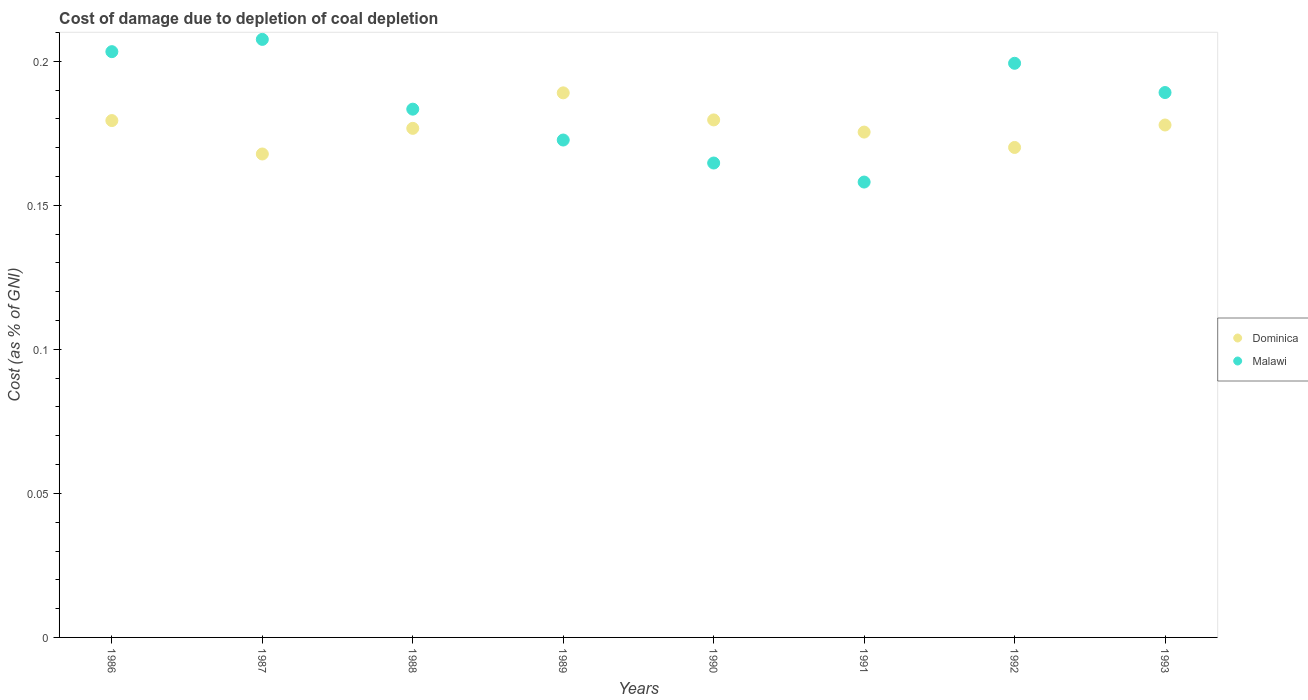What is the cost of damage caused due to coal depletion in Dominica in 1988?
Your answer should be very brief. 0.18. Across all years, what is the maximum cost of damage caused due to coal depletion in Dominica?
Ensure brevity in your answer.  0.19. Across all years, what is the minimum cost of damage caused due to coal depletion in Dominica?
Give a very brief answer. 0.17. What is the total cost of damage caused due to coal depletion in Dominica in the graph?
Your response must be concise. 1.42. What is the difference between the cost of damage caused due to coal depletion in Dominica in 1990 and that in 1991?
Your answer should be very brief. 0. What is the difference between the cost of damage caused due to coal depletion in Dominica in 1989 and the cost of damage caused due to coal depletion in Malawi in 1987?
Your response must be concise. -0.02. What is the average cost of damage caused due to coal depletion in Dominica per year?
Offer a terse response. 0.18. In the year 1989, what is the difference between the cost of damage caused due to coal depletion in Malawi and cost of damage caused due to coal depletion in Dominica?
Your answer should be very brief. -0.02. What is the ratio of the cost of damage caused due to coal depletion in Dominica in 1988 to that in 1991?
Give a very brief answer. 1.01. What is the difference between the highest and the second highest cost of damage caused due to coal depletion in Dominica?
Your response must be concise. 0.01. What is the difference between the highest and the lowest cost of damage caused due to coal depletion in Dominica?
Your answer should be compact. 0.02. In how many years, is the cost of damage caused due to coal depletion in Dominica greater than the average cost of damage caused due to coal depletion in Dominica taken over all years?
Provide a short and direct response. 4. Does the cost of damage caused due to coal depletion in Dominica monotonically increase over the years?
Ensure brevity in your answer.  No. Is the cost of damage caused due to coal depletion in Malawi strictly less than the cost of damage caused due to coal depletion in Dominica over the years?
Your answer should be very brief. No. Does the graph contain any zero values?
Offer a very short reply. No. Does the graph contain grids?
Make the answer very short. No. Where does the legend appear in the graph?
Ensure brevity in your answer.  Center right. How are the legend labels stacked?
Your answer should be compact. Vertical. What is the title of the graph?
Give a very brief answer. Cost of damage due to depletion of coal depletion. Does "El Salvador" appear as one of the legend labels in the graph?
Make the answer very short. No. What is the label or title of the Y-axis?
Make the answer very short. Cost (as % of GNI). What is the Cost (as % of GNI) of Dominica in 1986?
Keep it short and to the point. 0.18. What is the Cost (as % of GNI) of Malawi in 1986?
Provide a succinct answer. 0.2. What is the Cost (as % of GNI) of Dominica in 1987?
Provide a succinct answer. 0.17. What is the Cost (as % of GNI) in Malawi in 1987?
Offer a terse response. 0.21. What is the Cost (as % of GNI) in Dominica in 1988?
Give a very brief answer. 0.18. What is the Cost (as % of GNI) in Malawi in 1988?
Your response must be concise. 0.18. What is the Cost (as % of GNI) of Dominica in 1989?
Ensure brevity in your answer.  0.19. What is the Cost (as % of GNI) of Malawi in 1989?
Make the answer very short. 0.17. What is the Cost (as % of GNI) of Dominica in 1990?
Provide a succinct answer. 0.18. What is the Cost (as % of GNI) in Malawi in 1990?
Make the answer very short. 0.16. What is the Cost (as % of GNI) in Dominica in 1991?
Your answer should be compact. 0.18. What is the Cost (as % of GNI) in Malawi in 1991?
Provide a short and direct response. 0.16. What is the Cost (as % of GNI) in Dominica in 1992?
Your response must be concise. 0.17. What is the Cost (as % of GNI) in Malawi in 1992?
Your answer should be very brief. 0.2. What is the Cost (as % of GNI) in Dominica in 1993?
Give a very brief answer. 0.18. What is the Cost (as % of GNI) of Malawi in 1993?
Provide a succinct answer. 0.19. Across all years, what is the maximum Cost (as % of GNI) in Dominica?
Give a very brief answer. 0.19. Across all years, what is the maximum Cost (as % of GNI) in Malawi?
Your answer should be compact. 0.21. Across all years, what is the minimum Cost (as % of GNI) of Dominica?
Your answer should be compact. 0.17. Across all years, what is the minimum Cost (as % of GNI) in Malawi?
Your answer should be compact. 0.16. What is the total Cost (as % of GNI) of Dominica in the graph?
Offer a very short reply. 1.42. What is the total Cost (as % of GNI) in Malawi in the graph?
Keep it short and to the point. 1.48. What is the difference between the Cost (as % of GNI) of Dominica in 1986 and that in 1987?
Your answer should be compact. 0.01. What is the difference between the Cost (as % of GNI) of Malawi in 1986 and that in 1987?
Your answer should be very brief. -0. What is the difference between the Cost (as % of GNI) in Dominica in 1986 and that in 1988?
Provide a short and direct response. 0. What is the difference between the Cost (as % of GNI) of Malawi in 1986 and that in 1988?
Your response must be concise. 0.02. What is the difference between the Cost (as % of GNI) of Dominica in 1986 and that in 1989?
Offer a terse response. -0.01. What is the difference between the Cost (as % of GNI) in Malawi in 1986 and that in 1989?
Offer a terse response. 0.03. What is the difference between the Cost (as % of GNI) in Dominica in 1986 and that in 1990?
Give a very brief answer. -0. What is the difference between the Cost (as % of GNI) of Malawi in 1986 and that in 1990?
Your answer should be very brief. 0.04. What is the difference between the Cost (as % of GNI) in Dominica in 1986 and that in 1991?
Provide a succinct answer. 0. What is the difference between the Cost (as % of GNI) in Malawi in 1986 and that in 1991?
Provide a succinct answer. 0.05. What is the difference between the Cost (as % of GNI) in Dominica in 1986 and that in 1992?
Keep it short and to the point. 0.01. What is the difference between the Cost (as % of GNI) of Malawi in 1986 and that in 1992?
Your answer should be very brief. 0. What is the difference between the Cost (as % of GNI) of Dominica in 1986 and that in 1993?
Provide a succinct answer. 0. What is the difference between the Cost (as % of GNI) in Malawi in 1986 and that in 1993?
Your answer should be very brief. 0.01. What is the difference between the Cost (as % of GNI) of Dominica in 1987 and that in 1988?
Make the answer very short. -0.01. What is the difference between the Cost (as % of GNI) in Malawi in 1987 and that in 1988?
Keep it short and to the point. 0.02. What is the difference between the Cost (as % of GNI) in Dominica in 1987 and that in 1989?
Your answer should be very brief. -0.02. What is the difference between the Cost (as % of GNI) in Malawi in 1987 and that in 1989?
Provide a succinct answer. 0.03. What is the difference between the Cost (as % of GNI) of Dominica in 1987 and that in 1990?
Provide a short and direct response. -0.01. What is the difference between the Cost (as % of GNI) in Malawi in 1987 and that in 1990?
Keep it short and to the point. 0.04. What is the difference between the Cost (as % of GNI) in Dominica in 1987 and that in 1991?
Provide a short and direct response. -0.01. What is the difference between the Cost (as % of GNI) of Malawi in 1987 and that in 1991?
Your answer should be compact. 0.05. What is the difference between the Cost (as % of GNI) of Dominica in 1987 and that in 1992?
Your response must be concise. -0. What is the difference between the Cost (as % of GNI) in Malawi in 1987 and that in 1992?
Keep it short and to the point. 0.01. What is the difference between the Cost (as % of GNI) of Dominica in 1987 and that in 1993?
Give a very brief answer. -0.01. What is the difference between the Cost (as % of GNI) in Malawi in 1987 and that in 1993?
Offer a very short reply. 0.02. What is the difference between the Cost (as % of GNI) of Dominica in 1988 and that in 1989?
Your answer should be compact. -0.01. What is the difference between the Cost (as % of GNI) in Malawi in 1988 and that in 1989?
Your answer should be compact. 0.01. What is the difference between the Cost (as % of GNI) of Dominica in 1988 and that in 1990?
Ensure brevity in your answer.  -0. What is the difference between the Cost (as % of GNI) of Malawi in 1988 and that in 1990?
Offer a terse response. 0.02. What is the difference between the Cost (as % of GNI) in Dominica in 1988 and that in 1991?
Offer a very short reply. 0. What is the difference between the Cost (as % of GNI) in Malawi in 1988 and that in 1991?
Your response must be concise. 0.03. What is the difference between the Cost (as % of GNI) in Dominica in 1988 and that in 1992?
Offer a very short reply. 0.01. What is the difference between the Cost (as % of GNI) of Malawi in 1988 and that in 1992?
Give a very brief answer. -0.02. What is the difference between the Cost (as % of GNI) in Dominica in 1988 and that in 1993?
Your answer should be compact. -0. What is the difference between the Cost (as % of GNI) in Malawi in 1988 and that in 1993?
Your answer should be compact. -0.01. What is the difference between the Cost (as % of GNI) of Dominica in 1989 and that in 1990?
Your answer should be compact. 0.01. What is the difference between the Cost (as % of GNI) in Malawi in 1989 and that in 1990?
Ensure brevity in your answer.  0.01. What is the difference between the Cost (as % of GNI) of Dominica in 1989 and that in 1991?
Ensure brevity in your answer.  0.01. What is the difference between the Cost (as % of GNI) in Malawi in 1989 and that in 1991?
Give a very brief answer. 0.01. What is the difference between the Cost (as % of GNI) of Dominica in 1989 and that in 1992?
Provide a short and direct response. 0.02. What is the difference between the Cost (as % of GNI) of Malawi in 1989 and that in 1992?
Make the answer very short. -0.03. What is the difference between the Cost (as % of GNI) of Dominica in 1989 and that in 1993?
Your response must be concise. 0.01. What is the difference between the Cost (as % of GNI) of Malawi in 1989 and that in 1993?
Provide a succinct answer. -0.02. What is the difference between the Cost (as % of GNI) in Dominica in 1990 and that in 1991?
Offer a terse response. 0. What is the difference between the Cost (as % of GNI) in Malawi in 1990 and that in 1991?
Your answer should be compact. 0.01. What is the difference between the Cost (as % of GNI) in Dominica in 1990 and that in 1992?
Ensure brevity in your answer.  0.01. What is the difference between the Cost (as % of GNI) of Malawi in 1990 and that in 1992?
Your answer should be compact. -0.03. What is the difference between the Cost (as % of GNI) in Dominica in 1990 and that in 1993?
Ensure brevity in your answer.  0. What is the difference between the Cost (as % of GNI) of Malawi in 1990 and that in 1993?
Ensure brevity in your answer.  -0.02. What is the difference between the Cost (as % of GNI) of Dominica in 1991 and that in 1992?
Provide a succinct answer. 0.01. What is the difference between the Cost (as % of GNI) of Malawi in 1991 and that in 1992?
Make the answer very short. -0.04. What is the difference between the Cost (as % of GNI) of Dominica in 1991 and that in 1993?
Give a very brief answer. -0. What is the difference between the Cost (as % of GNI) of Malawi in 1991 and that in 1993?
Your answer should be very brief. -0.03. What is the difference between the Cost (as % of GNI) in Dominica in 1992 and that in 1993?
Give a very brief answer. -0.01. What is the difference between the Cost (as % of GNI) of Malawi in 1992 and that in 1993?
Offer a very short reply. 0.01. What is the difference between the Cost (as % of GNI) in Dominica in 1986 and the Cost (as % of GNI) in Malawi in 1987?
Keep it short and to the point. -0.03. What is the difference between the Cost (as % of GNI) of Dominica in 1986 and the Cost (as % of GNI) of Malawi in 1988?
Give a very brief answer. -0. What is the difference between the Cost (as % of GNI) in Dominica in 1986 and the Cost (as % of GNI) in Malawi in 1989?
Offer a very short reply. 0.01. What is the difference between the Cost (as % of GNI) of Dominica in 1986 and the Cost (as % of GNI) of Malawi in 1990?
Provide a short and direct response. 0.01. What is the difference between the Cost (as % of GNI) of Dominica in 1986 and the Cost (as % of GNI) of Malawi in 1991?
Make the answer very short. 0.02. What is the difference between the Cost (as % of GNI) in Dominica in 1986 and the Cost (as % of GNI) in Malawi in 1992?
Give a very brief answer. -0.02. What is the difference between the Cost (as % of GNI) in Dominica in 1986 and the Cost (as % of GNI) in Malawi in 1993?
Your answer should be compact. -0.01. What is the difference between the Cost (as % of GNI) of Dominica in 1987 and the Cost (as % of GNI) of Malawi in 1988?
Ensure brevity in your answer.  -0.02. What is the difference between the Cost (as % of GNI) in Dominica in 1987 and the Cost (as % of GNI) in Malawi in 1989?
Ensure brevity in your answer.  -0. What is the difference between the Cost (as % of GNI) in Dominica in 1987 and the Cost (as % of GNI) in Malawi in 1990?
Your response must be concise. 0. What is the difference between the Cost (as % of GNI) of Dominica in 1987 and the Cost (as % of GNI) of Malawi in 1991?
Make the answer very short. 0.01. What is the difference between the Cost (as % of GNI) in Dominica in 1987 and the Cost (as % of GNI) in Malawi in 1992?
Offer a terse response. -0.03. What is the difference between the Cost (as % of GNI) of Dominica in 1987 and the Cost (as % of GNI) of Malawi in 1993?
Your answer should be compact. -0.02. What is the difference between the Cost (as % of GNI) of Dominica in 1988 and the Cost (as % of GNI) of Malawi in 1989?
Ensure brevity in your answer.  0. What is the difference between the Cost (as % of GNI) in Dominica in 1988 and the Cost (as % of GNI) in Malawi in 1990?
Your response must be concise. 0.01. What is the difference between the Cost (as % of GNI) of Dominica in 1988 and the Cost (as % of GNI) of Malawi in 1991?
Your answer should be very brief. 0.02. What is the difference between the Cost (as % of GNI) of Dominica in 1988 and the Cost (as % of GNI) of Malawi in 1992?
Make the answer very short. -0.02. What is the difference between the Cost (as % of GNI) in Dominica in 1988 and the Cost (as % of GNI) in Malawi in 1993?
Provide a short and direct response. -0.01. What is the difference between the Cost (as % of GNI) of Dominica in 1989 and the Cost (as % of GNI) of Malawi in 1990?
Provide a succinct answer. 0.02. What is the difference between the Cost (as % of GNI) in Dominica in 1989 and the Cost (as % of GNI) in Malawi in 1991?
Keep it short and to the point. 0.03. What is the difference between the Cost (as % of GNI) of Dominica in 1989 and the Cost (as % of GNI) of Malawi in 1992?
Make the answer very short. -0.01. What is the difference between the Cost (as % of GNI) of Dominica in 1989 and the Cost (as % of GNI) of Malawi in 1993?
Make the answer very short. -0. What is the difference between the Cost (as % of GNI) in Dominica in 1990 and the Cost (as % of GNI) in Malawi in 1991?
Ensure brevity in your answer.  0.02. What is the difference between the Cost (as % of GNI) in Dominica in 1990 and the Cost (as % of GNI) in Malawi in 1992?
Give a very brief answer. -0.02. What is the difference between the Cost (as % of GNI) of Dominica in 1990 and the Cost (as % of GNI) of Malawi in 1993?
Keep it short and to the point. -0.01. What is the difference between the Cost (as % of GNI) in Dominica in 1991 and the Cost (as % of GNI) in Malawi in 1992?
Your answer should be compact. -0.02. What is the difference between the Cost (as % of GNI) of Dominica in 1991 and the Cost (as % of GNI) of Malawi in 1993?
Give a very brief answer. -0.01. What is the difference between the Cost (as % of GNI) in Dominica in 1992 and the Cost (as % of GNI) in Malawi in 1993?
Provide a short and direct response. -0.02. What is the average Cost (as % of GNI) in Dominica per year?
Offer a very short reply. 0.18. What is the average Cost (as % of GNI) of Malawi per year?
Offer a very short reply. 0.18. In the year 1986, what is the difference between the Cost (as % of GNI) of Dominica and Cost (as % of GNI) of Malawi?
Your answer should be compact. -0.02. In the year 1987, what is the difference between the Cost (as % of GNI) of Dominica and Cost (as % of GNI) of Malawi?
Ensure brevity in your answer.  -0.04. In the year 1988, what is the difference between the Cost (as % of GNI) of Dominica and Cost (as % of GNI) of Malawi?
Offer a terse response. -0.01. In the year 1989, what is the difference between the Cost (as % of GNI) in Dominica and Cost (as % of GNI) in Malawi?
Ensure brevity in your answer.  0.02. In the year 1990, what is the difference between the Cost (as % of GNI) in Dominica and Cost (as % of GNI) in Malawi?
Give a very brief answer. 0.01. In the year 1991, what is the difference between the Cost (as % of GNI) in Dominica and Cost (as % of GNI) in Malawi?
Offer a terse response. 0.02. In the year 1992, what is the difference between the Cost (as % of GNI) in Dominica and Cost (as % of GNI) in Malawi?
Offer a very short reply. -0.03. In the year 1993, what is the difference between the Cost (as % of GNI) in Dominica and Cost (as % of GNI) in Malawi?
Your answer should be compact. -0.01. What is the ratio of the Cost (as % of GNI) of Dominica in 1986 to that in 1987?
Offer a very short reply. 1.07. What is the ratio of the Cost (as % of GNI) in Malawi in 1986 to that in 1987?
Provide a short and direct response. 0.98. What is the ratio of the Cost (as % of GNI) of Dominica in 1986 to that in 1988?
Offer a terse response. 1.02. What is the ratio of the Cost (as % of GNI) of Malawi in 1986 to that in 1988?
Offer a terse response. 1.11. What is the ratio of the Cost (as % of GNI) of Dominica in 1986 to that in 1989?
Give a very brief answer. 0.95. What is the ratio of the Cost (as % of GNI) in Malawi in 1986 to that in 1989?
Keep it short and to the point. 1.18. What is the ratio of the Cost (as % of GNI) of Malawi in 1986 to that in 1990?
Your answer should be very brief. 1.23. What is the ratio of the Cost (as % of GNI) in Dominica in 1986 to that in 1991?
Your answer should be very brief. 1.02. What is the ratio of the Cost (as % of GNI) in Malawi in 1986 to that in 1991?
Make the answer very short. 1.29. What is the ratio of the Cost (as % of GNI) of Dominica in 1986 to that in 1992?
Provide a short and direct response. 1.05. What is the ratio of the Cost (as % of GNI) of Malawi in 1986 to that in 1992?
Provide a succinct answer. 1.02. What is the ratio of the Cost (as % of GNI) in Dominica in 1986 to that in 1993?
Keep it short and to the point. 1.01. What is the ratio of the Cost (as % of GNI) in Malawi in 1986 to that in 1993?
Your answer should be very brief. 1.07. What is the ratio of the Cost (as % of GNI) of Dominica in 1987 to that in 1988?
Provide a short and direct response. 0.95. What is the ratio of the Cost (as % of GNI) of Malawi in 1987 to that in 1988?
Offer a very short reply. 1.13. What is the ratio of the Cost (as % of GNI) of Dominica in 1987 to that in 1989?
Your response must be concise. 0.89. What is the ratio of the Cost (as % of GNI) in Malawi in 1987 to that in 1989?
Keep it short and to the point. 1.2. What is the ratio of the Cost (as % of GNI) of Dominica in 1987 to that in 1990?
Provide a succinct answer. 0.93. What is the ratio of the Cost (as % of GNI) in Malawi in 1987 to that in 1990?
Offer a very short reply. 1.26. What is the ratio of the Cost (as % of GNI) in Dominica in 1987 to that in 1991?
Provide a short and direct response. 0.96. What is the ratio of the Cost (as % of GNI) in Malawi in 1987 to that in 1991?
Make the answer very short. 1.31. What is the ratio of the Cost (as % of GNI) of Dominica in 1987 to that in 1992?
Your response must be concise. 0.99. What is the ratio of the Cost (as % of GNI) in Malawi in 1987 to that in 1992?
Provide a succinct answer. 1.04. What is the ratio of the Cost (as % of GNI) of Dominica in 1987 to that in 1993?
Ensure brevity in your answer.  0.94. What is the ratio of the Cost (as % of GNI) of Malawi in 1987 to that in 1993?
Provide a succinct answer. 1.1. What is the ratio of the Cost (as % of GNI) of Dominica in 1988 to that in 1989?
Offer a very short reply. 0.93. What is the ratio of the Cost (as % of GNI) in Malawi in 1988 to that in 1989?
Ensure brevity in your answer.  1.06. What is the ratio of the Cost (as % of GNI) in Dominica in 1988 to that in 1990?
Keep it short and to the point. 0.98. What is the ratio of the Cost (as % of GNI) in Malawi in 1988 to that in 1990?
Ensure brevity in your answer.  1.11. What is the ratio of the Cost (as % of GNI) in Dominica in 1988 to that in 1991?
Provide a short and direct response. 1.01. What is the ratio of the Cost (as % of GNI) in Malawi in 1988 to that in 1991?
Ensure brevity in your answer.  1.16. What is the ratio of the Cost (as % of GNI) of Dominica in 1988 to that in 1992?
Offer a terse response. 1.04. What is the ratio of the Cost (as % of GNI) of Malawi in 1988 to that in 1992?
Your response must be concise. 0.92. What is the ratio of the Cost (as % of GNI) of Malawi in 1988 to that in 1993?
Make the answer very short. 0.97. What is the ratio of the Cost (as % of GNI) of Dominica in 1989 to that in 1990?
Your response must be concise. 1.05. What is the ratio of the Cost (as % of GNI) of Malawi in 1989 to that in 1990?
Give a very brief answer. 1.05. What is the ratio of the Cost (as % of GNI) of Dominica in 1989 to that in 1991?
Ensure brevity in your answer.  1.08. What is the ratio of the Cost (as % of GNI) of Malawi in 1989 to that in 1991?
Your answer should be compact. 1.09. What is the ratio of the Cost (as % of GNI) in Dominica in 1989 to that in 1992?
Offer a very short reply. 1.11. What is the ratio of the Cost (as % of GNI) in Malawi in 1989 to that in 1992?
Your answer should be compact. 0.87. What is the ratio of the Cost (as % of GNI) in Dominica in 1989 to that in 1993?
Your response must be concise. 1.06. What is the ratio of the Cost (as % of GNI) of Malawi in 1989 to that in 1993?
Your answer should be very brief. 0.91. What is the ratio of the Cost (as % of GNI) of Dominica in 1990 to that in 1991?
Offer a very short reply. 1.02. What is the ratio of the Cost (as % of GNI) of Malawi in 1990 to that in 1991?
Provide a succinct answer. 1.04. What is the ratio of the Cost (as % of GNI) of Dominica in 1990 to that in 1992?
Give a very brief answer. 1.06. What is the ratio of the Cost (as % of GNI) of Malawi in 1990 to that in 1992?
Make the answer very short. 0.83. What is the ratio of the Cost (as % of GNI) of Dominica in 1990 to that in 1993?
Keep it short and to the point. 1.01. What is the ratio of the Cost (as % of GNI) in Malawi in 1990 to that in 1993?
Your answer should be very brief. 0.87. What is the ratio of the Cost (as % of GNI) in Dominica in 1991 to that in 1992?
Provide a short and direct response. 1.03. What is the ratio of the Cost (as % of GNI) in Malawi in 1991 to that in 1992?
Ensure brevity in your answer.  0.79. What is the ratio of the Cost (as % of GNI) of Dominica in 1991 to that in 1993?
Offer a terse response. 0.99. What is the ratio of the Cost (as % of GNI) in Malawi in 1991 to that in 1993?
Ensure brevity in your answer.  0.84. What is the ratio of the Cost (as % of GNI) of Dominica in 1992 to that in 1993?
Ensure brevity in your answer.  0.96. What is the ratio of the Cost (as % of GNI) in Malawi in 1992 to that in 1993?
Provide a short and direct response. 1.05. What is the difference between the highest and the second highest Cost (as % of GNI) of Dominica?
Provide a succinct answer. 0.01. What is the difference between the highest and the second highest Cost (as % of GNI) of Malawi?
Make the answer very short. 0. What is the difference between the highest and the lowest Cost (as % of GNI) in Dominica?
Keep it short and to the point. 0.02. What is the difference between the highest and the lowest Cost (as % of GNI) of Malawi?
Ensure brevity in your answer.  0.05. 